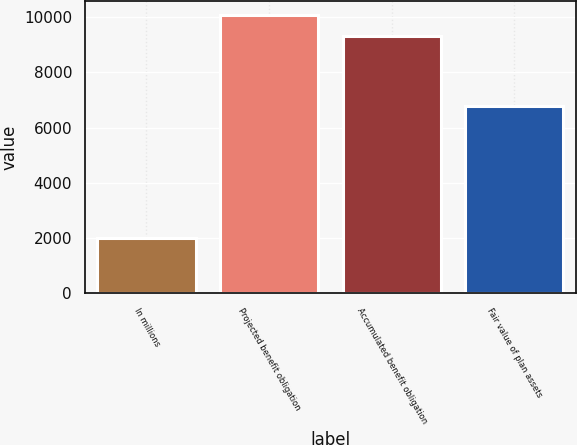<chart> <loc_0><loc_0><loc_500><loc_500><bar_chart><fcel>In millions<fcel>Projected benefit obligation<fcel>Accumulated benefit obligation<fcel>Fair value of plan assets<nl><fcel>2009<fcel>10065.5<fcel>9312<fcel>6784<nl></chart> 